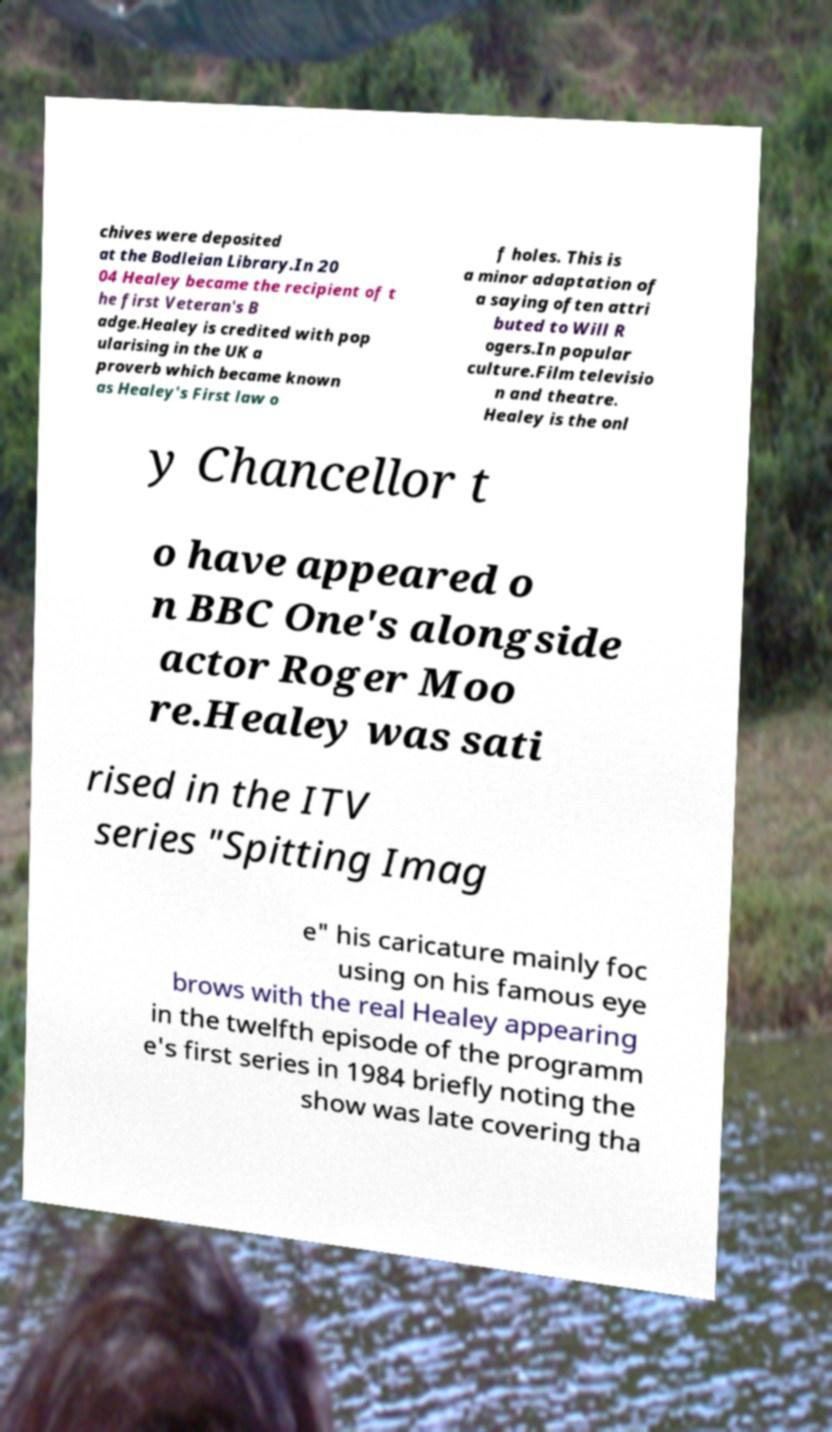What messages or text are displayed in this image? I need them in a readable, typed format. chives were deposited at the Bodleian Library.In 20 04 Healey became the recipient of t he first Veteran's B adge.Healey is credited with pop ularising in the UK a proverb which became known as Healey's First law o f holes. This is a minor adaptation of a saying often attri buted to Will R ogers.In popular culture.Film televisio n and theatre. Healey is the onl y Chancellor t o have appeared o n BBC One's alongside actor Roger Moo re.Healey was sati rised in the ITV series "Spitting Imag e" his caricature mainly foc using on his famous eye brows with the real Healey appearing in the twelfth episode of the programm e's first series in 1984 briefly noting the show was late covering tha 